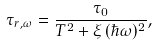Convert formula to latex. <formula><loc_0><loc_0><loc_500><loc_500>\tau _ { r , \omega } = { \frac { \tau _ { 0 } } { { T ^ { 2 } + \xi \, ( \hbar { \omega } ) ^ { 2 } } } } ,</formula> 